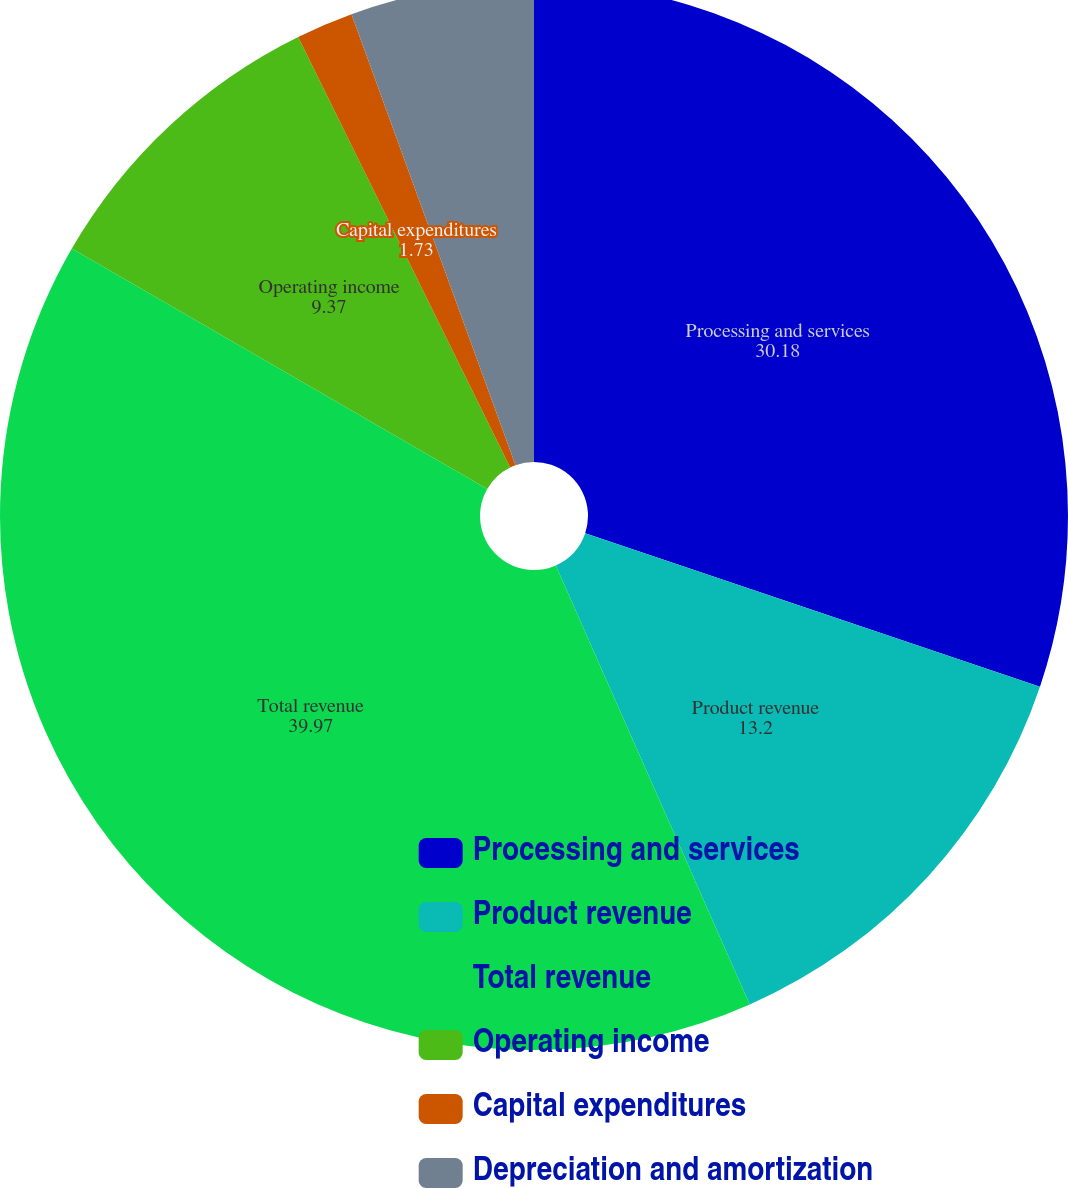Convert chart. <chart><loc_0><loc_0><loc_500><loc_500><pie_chart><fcel>Processing and services<fcel>Product revenue<fcel>Total revenue<fcel>Operating income<fcel>Capital expenditures<fcel>Depreciation and amortization<nl><fcel>30.18%<fcel>13.2%<fcel>39.97%<fcel>9.37%<fcel>1.73%<fcel>5.55%<nl></chart> 